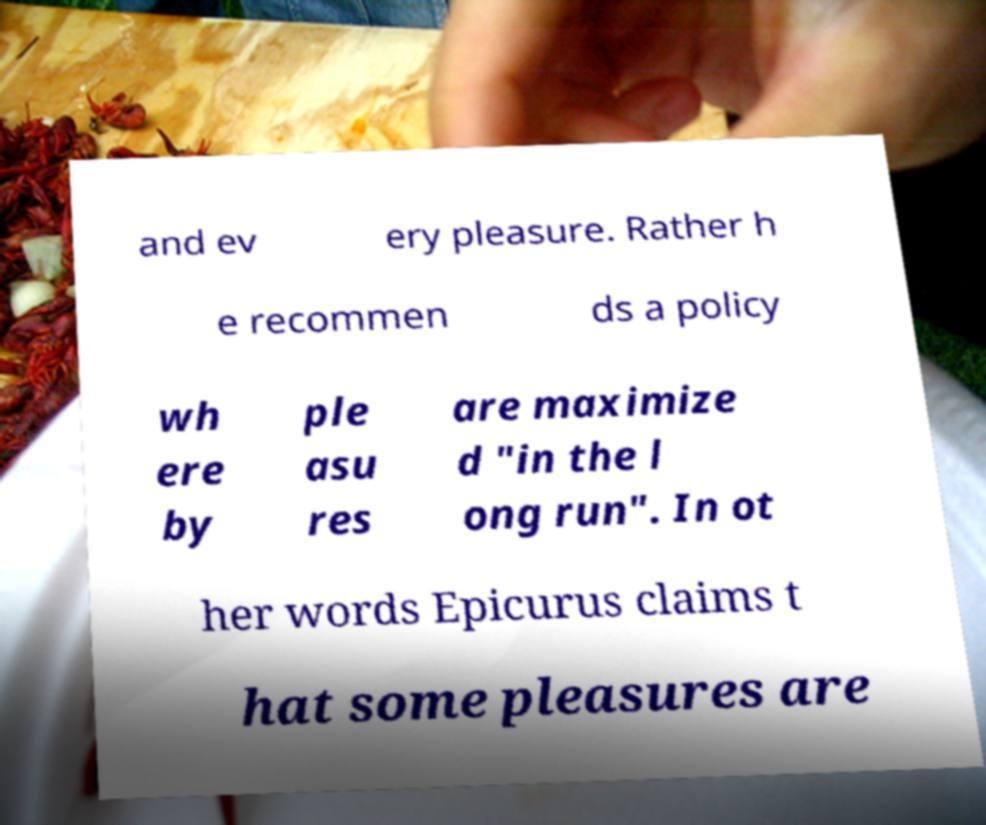Can you read and provide the text displayed in the image?This photo seems to have some interesting text. Can you extract and type it out for me? and ev ery pleasure. Rather h e recommen ds a policy wh ere by ple asu res are maximize d "in the l ong run". In ot her words Epicurus claims t hat some pleasures are 